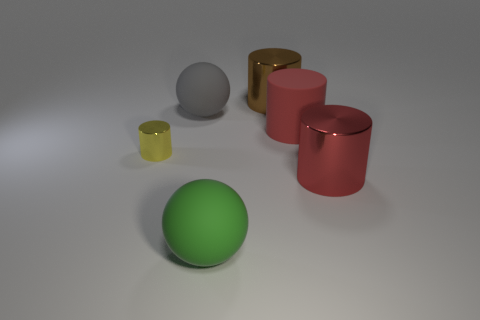The other ball that is the same material as the green sphere is what size?
Keep it short and to the point. Large. What is the large cylinder that is both behind the yellow metallic thing and in front of the big brown metallic cylinder made of?
Your answer should be very brief. Rubber. How many things are either objects that are on the left side of the big gray rubber sphere or large spheres behind the green object?
Offer a very short reply. 2. There is a green matte thing; is it the same shape as the matte object on the right side of the brown cylinder?
Offer a very short reply. No. There is a large rubber thing that is in front of the big metallic cylinder in front of the big cylinder left of the large red matte cylinder; what shape is it?
Keep it short and to the point. Sphere. How many other things are made of the same material as the green ball?
Ensure brevity in your answer.  2. How many things are metal things left of the brown metal thing or big things?
Provide a succinct answer. 6. The red object behind the large metal object right of the red rubber cylinder is what shape?
Provide a short and direct response. Cylinder. Does the big metallic thing that is behind the large gray thing have the same shape as the gray rubber object?
Your response must be concise. No. There is a rubber object to the right of the large brown object; what is its color?
Keep it short and to the point. Red. 